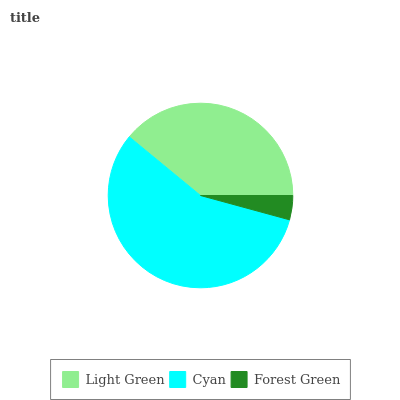Is Forest Green the minimum?
Answer yes or no. Yes. Is Cyan the maximum?
Answer yes or no. Yes. Is Cyan the minimum?
Answer yes or no. No. Is Forest Green the maximum?
Answer yes or no. No. Is Cyan greater than Forest Green?
Answer yes or no. Yes. Is Forest Green less than Cyan?
Answer yes or no. Yes. Is Forest Green greater than Cyan?
Answer yes or no. No. Is Cyan less than Forest Green?
Answer yes or no. No. Is Light Green the high median?
Answer yes or no. Yes. Is Light Green the low median?
Answer yes or no. Yes. Is Forest Green the high median?
Answer yes or no. No. Is Forest Green the low median?
Answer yes or no. No. 